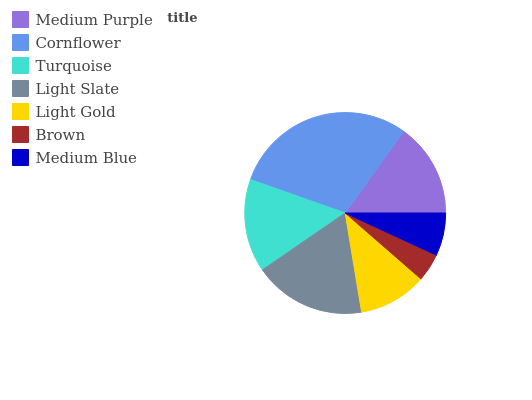Is Brown the minimum?
Answer yes or no. Yes. Is Cornflower the maximum?
Answer yes or no. Yes. Is Turquoise the minimum?
Answer yes or no. No. Is Turquoise the maximum?
Answer yes or no. No. Is Cornflower greater than Turquoise?
Answer yes or no. Yes. Is Turquoise less than Cornflower?
Answer yes or no. Yes. Is Turquoise greater than Cornflower?
Answer yes or no. No. Is Cornflower less than Turquoise?
Answer yes or no. No. Is Turquoise the high median?
Answer yes or no. Yes. Is Turquoise the low median?
Answer yes or no. Yes. Is Brown the high median?
Answer yes or no. No. Is Light Slate the low median?
Answer yes or no. No. 